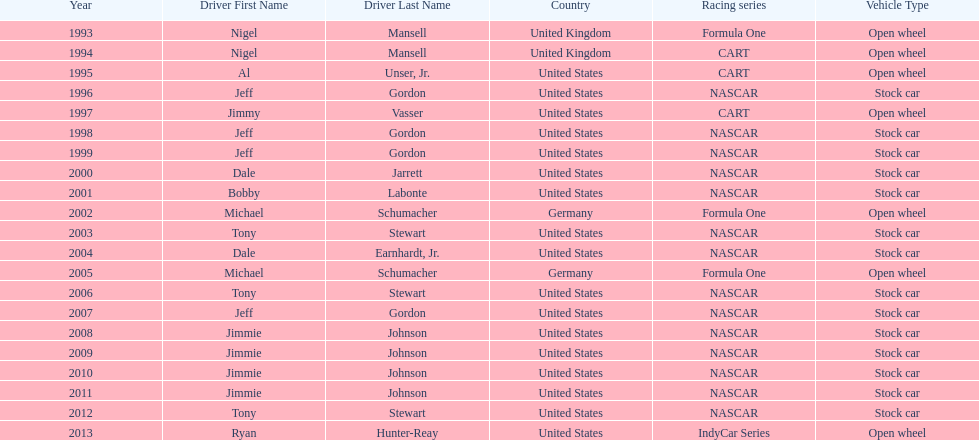How many times did jeff gordon win the award? 4. 